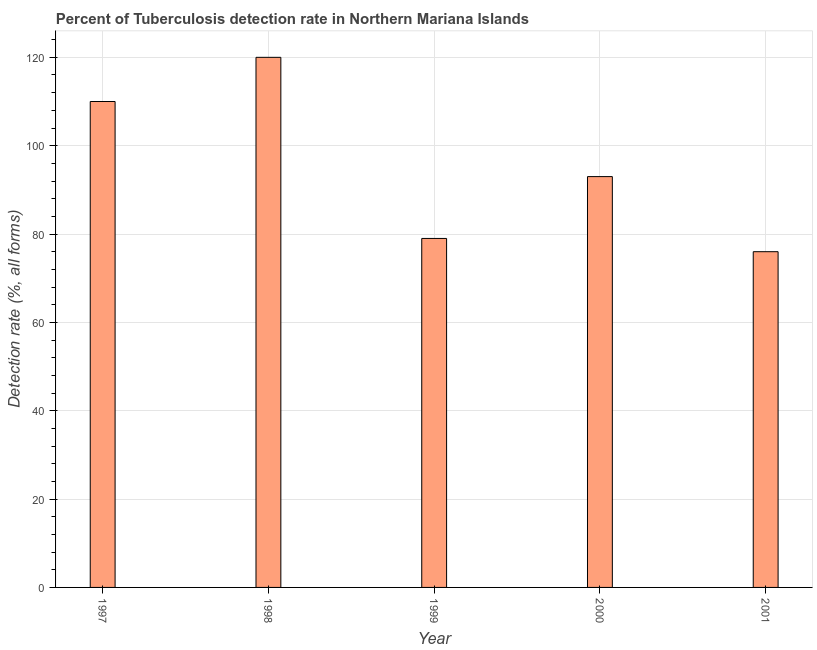Does the graph contain any zero values?
Give a very brief answer. No. Does the graph contain grids?
Offer a very short reply. Yes. What is the title of the graph?
Keep it short and to the point. Percent of Tuberculosis detection rate in Northern Mariana Islands. What is the label or title of the Y-axis?
Your answer should be compact. Detection rate (%, all forms). What is the detection rate of tuberculosis in 2000?
Offer a very short reply. 93. Across all years, what is the maximum detection rate of tuberculosis?
Your answer should be compact. 120. What is the sum of the detection rate of tuberculosis?
Your response must be concise. 478. What is the difference between the detection rate of tuberculosis in 1999 and 2000?
Ensure brevity in your answer.  -14. What is the average detection rate of tuberculosis per year?
Ensure brevity in your answer.  95. What is the median detection rate of tuberculosis?
Keep it short and to the point. 93. What is the ratio of the detection rate of tuberculosis in 2000 to that in 2001?
Make the answer very short. 1.22. Is the detection rate of tuberculosis in 1998 less than that in 2000?
Offer a very short reply. No. What is the difference between the highest and the lowest detection rate of tuberculosis?
Your response must be concise. 44. In how many years, is the detection rate of tuberculosis greater than the average detection rate of tuberculosis taken over all years?
Keep it short and to the point. 2. Are all the bars in the graph horizontal?
Keep it short and to the point. No. What is the Detection rate (%, all forms) in 1997?
Your answer should be compact. 110. What is the Detection rate (%, all forms) in 1998?
Offer a terse response. 120. What is the Detection rate (%, all forms) of 1999?
Keep it short and to the point. 79. What is the Detection rate (%, all forms) in 2000?
Your response must be concise. 93. What is the Detection rate (%, all forms) of 2001?
Ensure brevity in your answer.  76. What is the difference between the Detection rate (%, all forms) in 1997 and 2000?
Offer a terse response. 17. What is the difference between the Detection rate (%, all forms) in 1997 and 2001?
Give a very brief answer. 34. What is the difference between the Detection rate (%, all forms) in 1998 and 1999?
Your answer should be compact. 41. What is the difference between the Detection rate (%, all forms) in 1998 and 2000?
Provide a succinct answer. 27. What is the difference between the Detection rate (%, all forms) in 1999 and 2000?
Give a very brief answer. -14. What is the difference between the Detection rate (%, all forms) in 1999 and 2001?
Offer a very short reply. 3. What is the difference between the Detection rate (%, all forms) in 2000 and 2001?
Your answer should be compact. 17. What is the ratio of the Detection rate (%, all forms) in 1997 to that in 1998?
Your answer should be compact. 0.92. What is the ratio of the Detection rate (%, all forms) in 1997 to that in 1999?
Your answer should be compact. 1.39. What is the ratio of the Detection rate (%, all forms) in 1997 to that in 2000?
Provide a succinct answer. 1.18. What is the ratio of the Detection rate (%, all forms) in 1997 to that in 2001?
Offer a terse response. 1.45. What is the ratio of the Detection rate (%, all forms) in 1998 to that in 1999?
Provide a short and direct response. 1.52. What is the ratio of the Detection rate (%, all forms) in 1998 to that in 2000?
Offer a terse response. 1.29. What is the ratio of the Detection rate (%, all forms) in 1998 to that in 2001?
Provide a succinct answer. 1.58. What is the ratio of the Detection rate (%, all forms) in 1999 to that in 2000?
Give a very brief answer. 0.85. What is the ratio of the Detection rate (%, all forms) in 1999 to that in 2001?
Give a very brief answer. 1.04. What is the ratio of the Detection rate (%, all forms) in 2000 to that in 2001?
Provide a short and direct response. 1.22. 